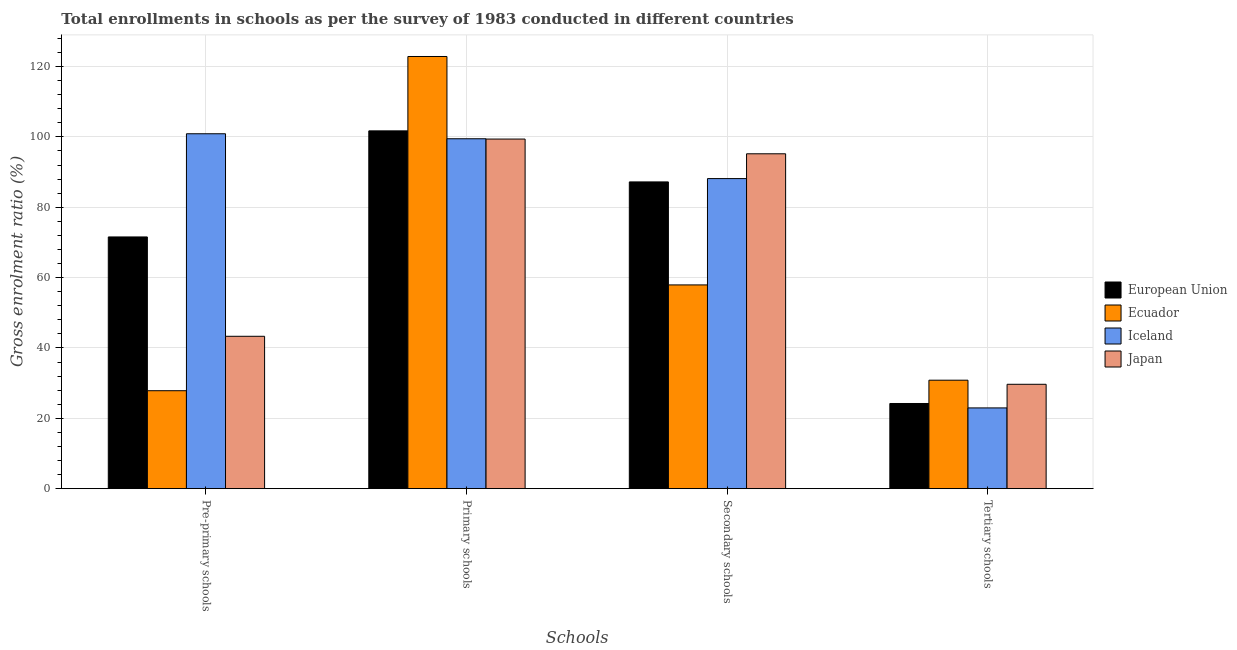Are the number of bars on each tick of the X-axis equal?
Provide a short and direct response. Yes. What is the label of the 4th group of bars from the left?
Offer a very short reply. Tertiary schools. What is the gross enrolment ratio in tertiary schools in European Union?
Offer a terse response. 24.21. Across all countries, what is the maximum gross enrolment ratio in pre-primary schools?
Provide a short and direct response. 100.88. Across all countries, what is the minimum gross enrolment ratio in tertiary schools?
Your answer should be very brief. 22.96. In which country was the gross enrolment ratio in primary schools maximum?
Ensure brevity in your answer.  Ecuador. In which country was the gross enrolment ratio in secondary schools minimum?
Keep it short and to the point. Ecuador. What is the total gross enrolment ratio in primary schools in the graph?
Offer a very short reply. 423.39. What is the difference between the gross enrolment ratio in pre-primary schools in European Union and that in Ecuador?
Your answer should be compact. 43.7. What is the difference between the gross enrolment ratio in tertiary schools in Ecuador and the gross enrolment ratio in primary schools in Iceland?
Ensure brevity in your answer.  -68.63. What is the average gross enrolment ratio in tertiary schools per country?
Offer a very short reply. 26.92. What is the difference between the gross enrolment ratio in pre-primary schools and gross enrolment ratio in secondary schools in Ecuador?
Your answer should be compact. -30.07. What is the ratio of the gross enrolment ratio in tertiary schools in Iceland to that in European Union?
Offer a very short reply. 0.95. Is the difference between the gross enrolment ratio in pre-primary schools in European Union and Ecuador greater than the difference between the gross enrolment ratio in secondary schools in European Union and Ecuador?
Offer a very short reply. Yes. What is the difference between the highest and the second highest gross enrolment ratio in tertiary schools?
Keep it short and to the point. 1.16. What is the difference between the highest and the lowest gross enrolment ratio in tertiary schools?
Offer a terse response. 7.88. In how many countries, is the gross enrolment ratio in secondary schools greater than the average gross enrolment ratio in secondary schools taken over all countries?
Offer a very short reply. 3. Is it the case that in every country, the sum of the gross enrolment ratio in tertiary schools and gross enrolment ratio in secondary schools is greater than the sum of gross enrolment ratio in primary schools and gross enrolment ratio in pre-primary schools?
Keep it short and to the point. No. What does the 2nd bar from the left in Secondary schools represents?
Offer a terse response. Ecuador. Is it the case that in every country, the sum of the gross enrolment ratio in pre-primary schools and gross enrolment ratio in primary schools is greater than the gross enrolment ratio in secondary schools?
Give a very brief answer. Yes. Are all the bars in the graph horizontal?
Give a very brief answer. No. What is the difference between two consecutive major ticks on the Y-axis?
Your answer should be very brief. 20. Does the graph contain grids?
Keep it short and to the point. Yes. How many legend labels are there?
Ensure brevity in your answer.  4. How are the legend labels stacked?
Offer a very short reply. Vertical. What is the title of the graph?
Offer a terse response. Total enrollments in schools as per the survey of 1983 conducted in different countries. Does "Cyprus" appear as one of the legend labels in the graph?
Give a very brief answer. No. What is the label or title of the X-axis?
Your answer should be compact. Schools. What is the Gross enrolment ratio (%) in European Union in Pre-primary schools?
Give a very brief answer. 71.55. What is the Gross enrolment ratio (%) of Ecuador in Pre-primary schools?
Offer a very short reply. 27.85. What is the Gross enrolment ratio (%) in Iceland in Pre-primary schools?
Offer a very short reply. 100.88. What is the Gross enrolment ratio (%) of Japan in Pre-primary schools?
Provide a succinct answer. 43.31. What is the Gross enrolment ratio (%) of European Union in Primary schools?
Offer a terse response. 101.7. What is the Gross enrolment ratio (%) in Ecuador in Primary schools?
Your response must be concise. 122.85. What is the Gross enrolment ratio (%) in Iceland in Primary schools?
Ensure brevity in your answer.  99.46. What is the Gross enrolment ratio (%) in Japan in Primary schools?
Provide a succinct answer. 99.38. What is the Gross enrolment ratio (%) in European Union in Secondary schools?
Make the answer very short. 87.2. What is the Gross enrolment ratio (%) in Ecuador in Secondary schools?
Keep it short and to the point. 57.92. What is the Gross enrolment ratio (%) of Iceland in Secondary schools?
Provide a succinct answer. 88.14. What is the Gross enrolment ratio (%) in Japan in Secondary schools?
Give a very brief answer. 95.19. What is the Gross enrolment ratio (%) of European Union in Tertiary schools?
Your response must be concise. 24.21. What is the Gross enrolment ratio (%) of Ecuador in Tertiary schools?
Your response must be concise. 30.83. What is the Gross enrolment ratio (%) of Iceland in Tertiary schools?
Your answer should be very brief. 22.96. What is the Gross enrolment ratio (%) in Japan in Tertiary schools?
Your answer should be very brief. 29.67. Across all Schools, what is the maximum Gross enrolment ratio (%) of European Union?
Your answer should be compact. 101.7. Across all Schools, what is the maximum Gross enrolment ratio (%) in Ecuador?
Offer a terse response. 122.85. Across all Schools, what is the maximum Gross enrolment ratio (%) of Iceland?
Provide a short and direct response. 100.88. Across all Schools, what is the maximum Gross enrolment ratio (%) of Japan?
Offer a very short reply. 99.38. Across all Schools, what is the minimum Gross enrolment ratio (%) in European Union?
Offer a very short reply. 24.21. Across all Schools, what is the minimum Gross enrolment ratio (%) of Ecuador?
Ensure brevity in your answer.  27.85. Across all Schools, what is the minimum Gross enrolment ratio (%) in Iceland?
Make the answer very short. 22.96. Across all Schools, what is the minimum Gross enrolment ratio (%) of Japan?
Provide a short and direct response. 29.67. What is the total Gross enrolment ratio (%) in European Union in the graph?
Give a very brief answer. 284.67. What is the total Gross enrolment ratio (%) of Ecuador in the graph?
Make the answer very short. 239.45. What is the total Gross enrolment ratio (%) in Iceland in the graph?
Your response must be concise. 311.44. What is the total Gross enrolment ratio (%) in Japan in the graph?
Make the answer very short. 267.56. What is the difference between the Gross enrolment ratio (%) of European Union in Pre-primary schools and that in Primary schools?
Keep it short and to the point. -30.15. What is the difference between the Gross enrolment ratio (%) of Ecuador in Pre-primary schools and that in Primary schools?
Offer a terse response. -95. What is the difference between the Gross enrolment ratio (%) in Iceland in Pre-primary schools and that in Primary schools?
Keep it short and to the point. 1.42. What is the difference between the Gross enrolment ratio (%) in Japan in Pre-primary schools and that in Primary schools?
Provide a short and direct response. -56.06. What is the difference between the Gross enrolment ratio (%) in European Union in Pre-primary schools and that in Secondary schools?
Make the answer very short. -15.64. What is the difference between the Gross enrolment ratio (%) in Ecuador in Pre-primary schools and that in Secondary schools?
Offer a terse response. -30.07. What is the difference between the Gross enrolment ratio (%) in Iceland in Pre-primary schools and that in Secondary schools?
Ensure brevity in your answer.  12.74. What is the difference between the Gross enrolment ratio (%) of Japan in Pre-primary schools and that in Secondary schools?
Provide a succinct answer. -51.88. What is the difference between the Gross enrolment ratio (%) of European Union in Pre-primary schools and that in Tertiary schools?
Provide a short and direct response. 47.34. What is the difference between the Gross enrolment ratio (%) of Ecuador in Pre-primary schools and that in Tertiary schools?
Your answer should be compact. -2.99. What is the difference between the Gross enrolment ratio (%) in Iceland in Pre-primary schools and that in Tertiary schools?
Your response must be concise. 77.93. What is the difference between the Gross enrolment ratio (%) in Japan in Pre-primary schools and that in Tertiary schools?
Ensure brevity in your answer.  13.64. What is the difference between the Gross enrolment ratio (%) in European Union in Primary schools and that in Secondary schools?
Offer a very short reply. 14.51. What is the difference between the Gross enrolment ratio (%) of Ecuador in Primary schools and that in Secondary schools?
Your response must be concise. 64.93. What is the difference between the Gross enrolment ratio (%) of Iceland in Primary schools and that in Secondary schools?
Provide a succinct answer. 11.32. What is the difference between the Gross enrolment ratio (%) in Japan in Primary schools and that in Secondary schools?
Offer a terse response. 4.19. What is the difference between the Gross enrolment ratio (%) in European Union in Primary schools and that in Tertiary schools?
Your answer should be very brief. 77.49. What is the difference between the Gross enrolment ratio (%) of Ecuador in Primary schools and that in Tertiary schools?
Provide a succinct answer. 92.01. What is the difference between the Gross enrolment ratio (%) of Iceland in Primary schools and that in Tertiary schools?
Keep it short and to the point. 76.51. What is the difference between the Gross enrolment ratio (%) in Japan in Primary schools and that in Tertiary schools?
Provide a short and direct response. 69.7. What is the difference between the Gross enrolment ratio (%) of European Union in Secondary schools and that in Tertiary schools?
Provide a short and direct response. 62.98. What is the difference between the Gross enrolment ratio (%) in Ecuador in Secondary schools and that in Tertiary schools?
Make the answer very short. 27.08. What is the difference between the Gross enrolment ratio (%) in Iceland in Secondary schools and that in Tertiary schools?
Make the answer very short. 65.18. What is the difference between the Gross enrolment ratio (%) in Japan in Secondary schools and that in Tertiary schools?
Make the answer very short. 65.52. What is the difference between the Gross enrolment ratio (%) in European Union in Pre-primary schools and the Gross enrolment ratio (%) in Ecuador in Primary schools?
Make the answer very short. -51.3. What is the difference between the Gross enrolment ratio (%) in European Union in Pre-primary schools and the Gross enrolment ratio (%) in Iceland in Primary schools?
Your answer should be very brief. -27.91. What is the difference between the Gross enrolment ratio (%) in European Union in Pre-primary schools and the Gross enrolment ratio (%) in Japan in Primary schools?
Provide a succinct answer. -27.82. What is the difference between the Gross enrolment ratio (%) in Ecuador in Pre-primary schools and the Gross enrolment ratio (%) in Iceland in Primary schools?
Keep it short and to the point. -71.62. What is the difference between the Gross enrolment ratio (%) of Ecuador in Pre-primary schools and the Gross enrolment ratio (%) of Japan in Primary schools?
Offer a very short reply. -71.53. What is the difference between the Gross enrolment ratio (%) in Iceland in Pre-primary schools and the Gross enrolment ratio (%) in Japan in Primary schools?
Offer a terse response. 1.5. What is the difference between the Gross enrolment ratio (%) in European Union in Pre-primary schools and the Gross enrolment ratio (%) in Ecuador in Secondary schools?
Your response must be concise. 13.64. What is the difference between the Gross enrolment ratio (%) of European Union in Pre-primary schools and the Gross enrolment ratio (%) of Iceland in Secondary schools?
Your response must be concise. -16.59. What is the difference between the Gross enrolment ratio (%) in European Union in Pre-primary schools and the Gross enrolment ratio (%) in Japan in Secondary schools?
Provide a succinct answer. -23.64. What is the difference between the Gross enrolment ratio (%) in Ecuador in Pre-primary schools and the Gross enrolment ratio (%) in Iceland in Secondary schools?
Provide a short and direct response. -60.29. What is the difference between the Gross enrolment ratio (%) in Ecuador in Pre-primary schools and the Gross enrolment ratio (%) in Japan in Secondary schools?
Make the answer very short. -67.34. What is the difference between the Gross enrolment ratio (%) of Iceland in Pre-primary schools and the Gross enrolment ratio (%) of Japan in Secondary schools?
Offer a very short reply. 5.69. What is the difference between the Gross enrolment ratio (%) of European Union in Pre-primary schools and the Gross enrolment ratio (%) of Ecuador in Tertiary schools?
Provide a short and direct response. 40.72. What is the difference between the Gross enrolment ratio (%) of European Union in Pre-primary schools and the Gross enrolment ratio (%) of Iceland in Tertiary schools?
Provide a short and direct response. 48.6. What is the difference between the Gross enrolment ratio (%) in European Union in Pre-primary schools and the Gross enrolment ratio (%) in Japan in Tertiary schools?
Give a very brief answer. 41.88. What is the difference between the Gross enrolment ratio (%) in Ecuador in Pre-primary schools and the Gross enrolment ratio (%) in Iceland in Tertiary schools?
Offer a very short reply. 4.89. What is the difference between the Gross enrolment ratio (%) in Ecuador in Pre-primary schools and the Gross enrolment ratio (%) in Japan in Tertiary schools?
Offer a very short reply. -1.83. What is the difference between the Gross enrolment ratio (%) of Iceland in Pre-primary schools and the Gross enrolment ratio (%) of Japan in Tertiary schools?
Offer a very short reply. 71.21. What is the difference between the Gross enrolment ratio (%) of European Union in Primary schools and the Gross enrolment ratio (%) of Ecuador in Secondary schools?
Ensure brevity in your answer.  43.79. What is the difference between the Gross enrolment ratio (%) of European Union in Primary schools and the Gross enrolment ratio (%) of Iceland in Secondary schools?
Your response must be concise. 13.57. What is the difference between the Gross enrolment ratio (%) in European Union in Primary schools and the Gross enrolment ratio (%) in Japan in Secondary schools?
Ensure brevity in your answer.  6.51. What is the difference between the Gross enrolment ratio (%) of Ecuador in Primary schools and the Gross enrolment ratio (%) of Iceland in Secondary schools?
Give a very brief answer. 34.71. What is the difference between the Gross enrolment ratio (%) in Ecuador in Primary schools and the Gross enrolment ratio (%) in Japan in Secondary schools?
Your response must be concise. 27.66. What is the difference between the Gross enrolment ratio (%) in Iceland in Primary schools and the Gross enrolment ratio (%) in Japan in Secondary schools?
Offer a terse response. 4.27. What is the difference between the Gross enrolment ratio (%) of European Union in Primary schools and the Gross enrolment ratio (%) of Ecuador in Tertiary schools?
Offer a very short reply. 70.87. What is the difference between the Gross enrolment ratio (%) in European Union in Primary schools and the Gross enrolment ratio (%) in Iceland in Tertiary schools?
Your answer should be compact. 78.75. What is the difference between the Gross enrolment ratio (%) in European Union in Primary schools and the Gross enrolment ratio (%) in Japan in Tertiary schools?
Your answer should be very brief. 72.03. What is the difference between the Gross enrolment ratio (%) of Ecuador in Primary schools and the Gross enrolment ratio (%) of Iceland in Tertiary schools?
Ensure brevity in your answer.  99.89. What is the difference between the Gross enrolment ratio (%) in Ecuador in Primary schools and the Gross enrolment ratio (%) in Japan in Tertiary schools?
Keep it short and to the point. 93.17. What is the difference between the Gross enrolment ratio (%) of Iceland in Primary schools and the Gross enrolment ratio (%) of Japan in Tertiary schools?
Provide a short and direct response. 69.79. What is the difference between the Gross enrolment ratio (%) of European Union in Secondary schools and the Gross enrolment ratio (%) of Ecuador in Tertiary schools?
Keep it short and to the point. 56.36. What is the difference between the Gross enrolment ratio (%) of European Union in Secondary schools and the Gross enrolment ratio (%) of Iceland in Tertiary schools?
Provide a short and direct response. 64.24. What is the difference between the Gross enrolment ratio (%) in European Union in Secondary schools and the Gross enrolment ratio (%) in Japan in Tertiary schools?
Give a very brief answer. 57.52. What is the difference between the Gross enrolment ratio (%) in Ecuador in Secondary schools and the Gross enrolment ratio (%) in Iceland in Tertiary schools?
Make the answer very short. 34.96. What is the difference between the Gross enrolment ratio (%) of Ecuador in Secondary schools and the Gross enrolment ratio (%) of Japan in Tertiary schools?
Ensure brevity in your answer.  28.24. What is the difference between the Gross enrolment ratio (%) in Iceland in Secondary schools and the Gross enrolment ratio (%) in Japan in Tertiary schools?
Provide a short and direct response. 58.47. What is the average Gross enrolment ratio (%) of European Union per Schools?
Give a very brief answer. 71.17. What is the average Gross enrolment ratio (%) of Ecuador per Schools?
Provide a succinct answer. 59.86. What is the average Gross enrolment ratio (%) in Iceland per Schools?
Offer a very short reply. 77.86. What is the average Gross enrolment ratio (%) in Japan per Schools?
Your answer should be compact. 66.89. What is the difference between the Gross enrolment ratio (%) in European Union and Gross enrolment ratio (%) in Ecuador in Pre-primary schools?
Offer a very short reply. 43.7. What is the difference between the Gross enrolment ratio (%) in European Union and Gross enrolment ratio (%) in Iceland in Pre-primary schools?
Offer a very short reply. -29.33. What is the difference between the Gross enrolment ratio (%) in European Union and Gross enrolment ratio (%) in Japan in Pre-primary schools?
Offer a terse response. 28.24. What is the difference between the Gross enrolment ratio (%) in Ecuador and Gross enrolment ratio (%) in Iceland in Pre-primary schools?
Your answer should be compact. -73.03. What is the difference between the Gross enrolment ratio (%) of Ecuador and Gross enrolment ratio (%) of Japan in Pre-primary schools?
Provide a succinct answer. -15.47. What is the difference between the Gross enrolment ratio (%) in Iceland and Gross enrolment ratio (%) in Japan in Pre-primary schools?
Give a very brief answer. 57.57. What is the difference between the Gross enrolment ratio (%) in European Union and Gross enrolment ratio (%) in Ecuador in Primary schools?
Ensure brevity in your answer.  -21.14. What is the difference between the Gross enrolment ratio (%) of European Union and Gross enrolment ratio (%) of Iceland in Primary schools?
Provide a short and direct response. 2.24. What is the difference between the Gross enrolment ratio (%) of European Union and Gross enrolment ratio (%) of Japan in Primary schools?
Offer a terse response. 2.33. What is the difference between the Gross enrolment ratio (%) in Ecuador and Gross enrolment ratio (%) in Iceland in Primary schools?
Your answer should be very brief. 23.38. What is the difference between the Gross enrolment ratio (%) in Ecuador and Gross enrolment ratio (%) in Japan in Primary schools?
Give a very brief answer. 23.47. What is the difference between the Gross enrolment ratio (%) of Iceland and Gross enrolment ratio (%) of Japan in Primary schools?
Provide a succinct answer. 0.09. What is the difference between the Gross enrolment ratio (%) in European Union and Gross enrolment ratio (%) in Ecuador in Secondary schools?
Offer a terse response. 29.28. What is the difference between the Gross enrolment ratio (%) in European Union and Gross enrolment ratio (%) in Iceland in Secondary schools?
Keep it short and to the point. -0.94. What is the difference between the Gross enrolment ratio (%) of European Union and Gross enrolment ratio (%) of Japan in Secondary schools?
Provide a short and direct response. -7.99. What is the difference between the Gross enrolment ratio (%) of Ecuador and Gross enrolment ratio (%) of Iceland in Secondary schools?
Offer a very short reply. -30.22. What is the difference between the Gross enrolment ratio (%) in Ecuador and Gross enrolment ratio (%) in Japan in Secondary schools?
Provide a succinct answer. -37.27. What is the difference between the Gross enrolment ratio (%) in Iceland and Gross enrolment ratio (%) in Japan in Secondary schools?
Ensure brevity in your answer.  -7.05. What is the difference between the Gross enrolment ratio (%) of European Union and Gross enrolment ratio (%) of Ecuador in Tertiary schools?
Ensure brevity in your answer.  -6.62. What is the difference between the Gross enrolment ratio (%) in European Union and Gross enrolment ratio (%) in Iceland in Tertiary schools?
Your answer should be compact. 1.26. What is the difference between the Gross enrolment ratio (%) of European Union and Gross enrolment ratio (%) of Japan in Tertiary schools?
Ensure brevity in your answer.  -5.46. What is the difference between the Gross enrolment ratio (%) of Ecuador and Gross enrolment ratio (%) of Iceland in Tertiary schools?
Provide a short and direct response. 7.88. What is the difference between the Gross enrolment ratio (%) in Ecuador and Gross enrolment ratio (%) in Japan in Tertiary schools?
Ensure brevity in your answer.  1.16. What is the difference between the Gross enrolment ratio (%) of Iceland and Gross enrolment ratio (%) of Japan in Tertiary schools?
Keep it short and to the point. -6.72. What is the ratio of the Gross enrolment ratio (%) in European Union in Pre-primary schools to that in Primary schools?
Your response must be concise. 0.7. What is the ratio of the Gross enrolment ratio (%) of Ecuador in Pre-primary schools to that in Primary schools?
Your response must be concise. 0.23. What is the ratio of the Gross enrolment ratio (%) in Iceland in Pre-primary schools to that in Primary schools?
Keep it short and to the point. 1.01. What is the ratio of the Gross enrolment ratio (%) in Japan in Pre-primary schools to that in Primary schools?
Provide a succinct answer. 0.44. What is the ratio of the Gross enrolment ratio (%) of European Union in Pre-primary schools to that in Secondary schools?
Your answer should be compact. 0.82. What is the ratio of the Gross enrolment ratio (%) of Ecuador in Pre-primary schools to that in Secondary schools?
Provide a short and direct response. 0.48. What is the ratio of the Gross enrolment ratio (%) in Iceland in Pre-primary schools to that in Secondary schools?
Your answer should be very brief. 1.14. What is the ratio of the Gross enrolment ratio (%) of Japan in Pre-primary schools to that in Secondary schools?
Offer a terse response. 0.46. What is the ratio of the Gross enrolment ratio (%) in European Union in Pre-primary schools to that in Tertiary schools?
Provide a short and direct response. 2.96. What is the ratio of the Gross enrolment ratio (%) in Ecuador in Pre-primary schools to that in Tertiary schools?
Offer a very short reply. 0.9. What is the ratio of the Gross enrolment ratio (%) in Iceland in Pre-primary schools to that in Tertiary schools?
Give a very brief answer. 4.39. What is the ratio of the Gross enrolment ratio (%) of Japan in Pre-primary schools to that in Tertiary schools?
Your response must be concise. 1.46. What is the ratio of the Gross enrolment ratio (%) of European Union in Primary schools to that in Secondary schools?
Your answer should be very brief. 1.17. What is the ratio of the Gross enrolment ratio (%) of Ecuador in Primary schools to that in Secondary schools?
Ensure brevity in your answer.  2.12. What is the ratio of the Gross enrolment ratio (%) of Iceland in Primary schools to that in Secondary schools?
Keep it short and to the point. 1.13. What is the ratio of the Gross enrolment ratio (%) in Japan in Primary schools to that in Secondary schools?
Your answer should be very brief. 1.04. What is the ratio of the Gross enrolment ratio (%) in European Union in Primary schools to that in Tertiary schools?
Make the answer very short. 4.2. What is the ratio of the Gross enrolment ratio (%) of Ecuador in Primary schools to that in Tertiary schools?
Make the answer very short. 3.98. What is the ratio of the Gross enrolment ratio (%) in Iceland in Primary schools to that in Tertiary schools?
Your response must be concise. 4.33. What is the ratio of the Gross enrolment ratio (%) in Japan in Primary schools to that in Tertiary schools?
Offer a terse response. 3.35. What is the ratio of the Gross enrolment ratio (%) of European Union in Secondary schools to that in Tertiary schools?
Ensure brevity in your answer.  3.6. What is the ratio of the Gross enrolment ratio (%) in Ecuador in Secondary schools to that in Tertiary schools?
Offer a terse response. 1.88. What is the ratio of the Gross enrolment ratio (%) of Iceland in Secondary schools to that in Tertiary schools?
Keep it short and to the point. 3.84. What is the ratio of the Gross enrolment ratio (%) of Japan in Secondary schools to that in Tertiary schools?
Offer a terse response. 3.21. What is the difference between the highest and the second highest Gross enrolment ratio (%) in European Union?
Provide a short and direct response. 14.51. What is the difference between the highest and the second highest Gross enrolment ratio (%) in Ecuador?
Provide a short and direct response. 64.93. What is the difference between the highest and the second highest Gross enrolment ratio (%) in Iceland?
Provide a succinct answer. 1.42. What is the difference between the highest and the second highest Gross enrolment ratio (%) of Japan?
Give a very brief answer. 4.19. What is the difference between the highest and the lowest Gross enrolment ratio (%) in European Union?
Give a very brief answer. 77.49. What is the difference between the highest and the lowest Gross enrolment ratio (%) in Iceland?
Ensure brevity in your answer.  77.93. What is the difference between the highest and the lowest Gross enrolment ratio (%) of Japan?
Make the answer very short. 69.7. 